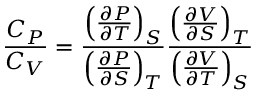Convert formula to latex. <formula><loc_0><loc_0><loc_500><loc_500>{ \frac { C _ { P } } { C _ { V } } } = { \frac { \left ( { \frac { \partial P } { \partial T } } \right ) _ { S } } { \left ( { \frac { \partial P } { \partial S } } \right ) _ { T } } } { \frac { \left ( { \frac { \partial V } { \partial S } } \right ) _ { T } } { \left ( { \frac { \partial V } { \partial T } } \right ) _ { S } } }</formula> 